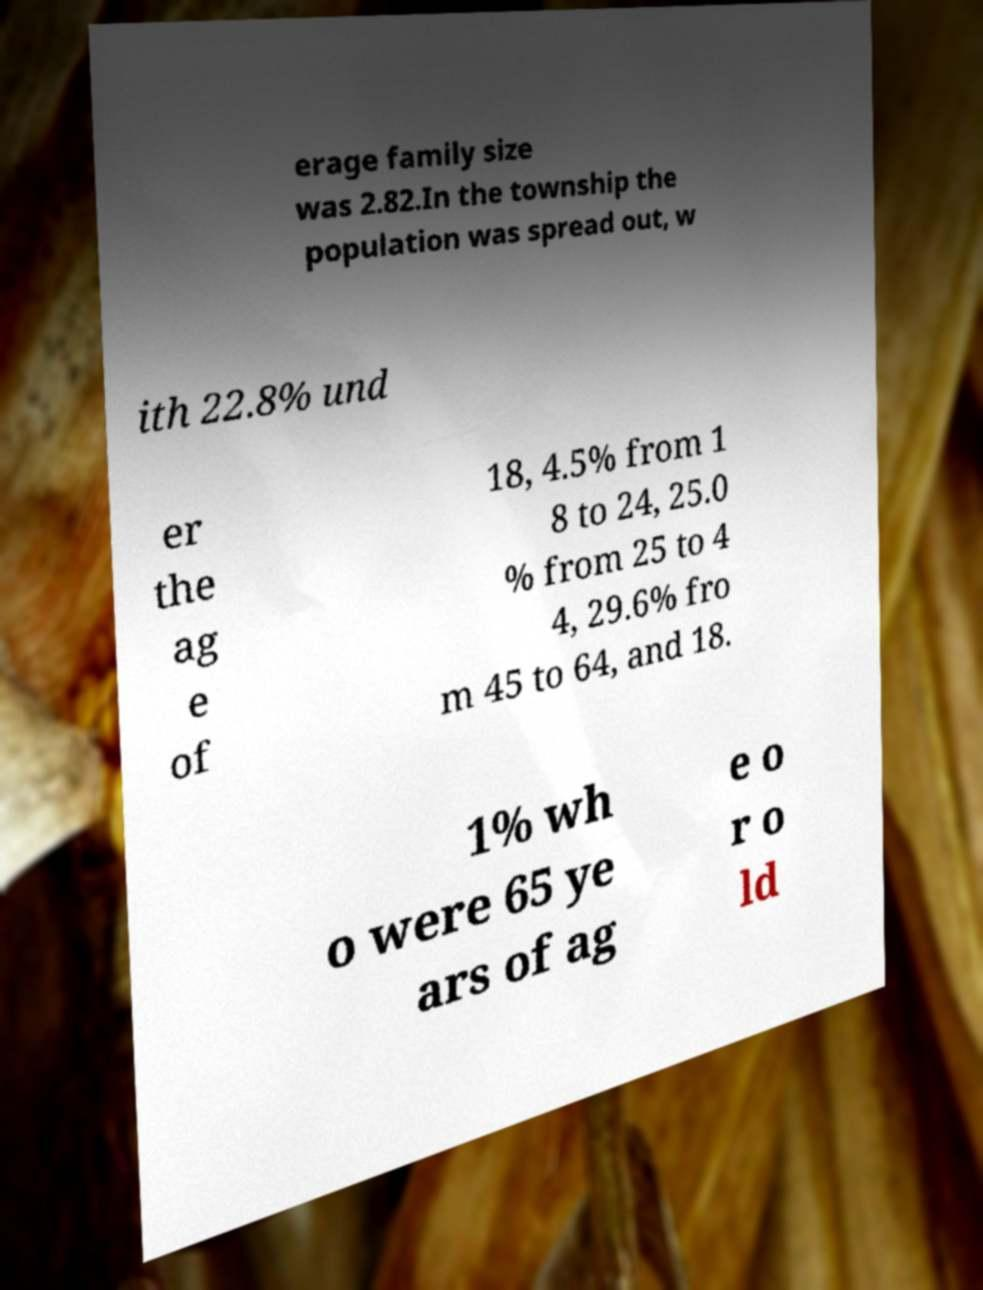Can you accurately transcribe the text from the provided image for me? erage family size was 2.82.In the township the population was spread out, w ith 22.8% und er the ag e of 18, 4.5% from 1 8 to 24, 25.0 % from 25 to 4 4, 29.6% fro m 45 to 64, and 18. 1% wh o were 65 ye ars of ag e o r o ld 